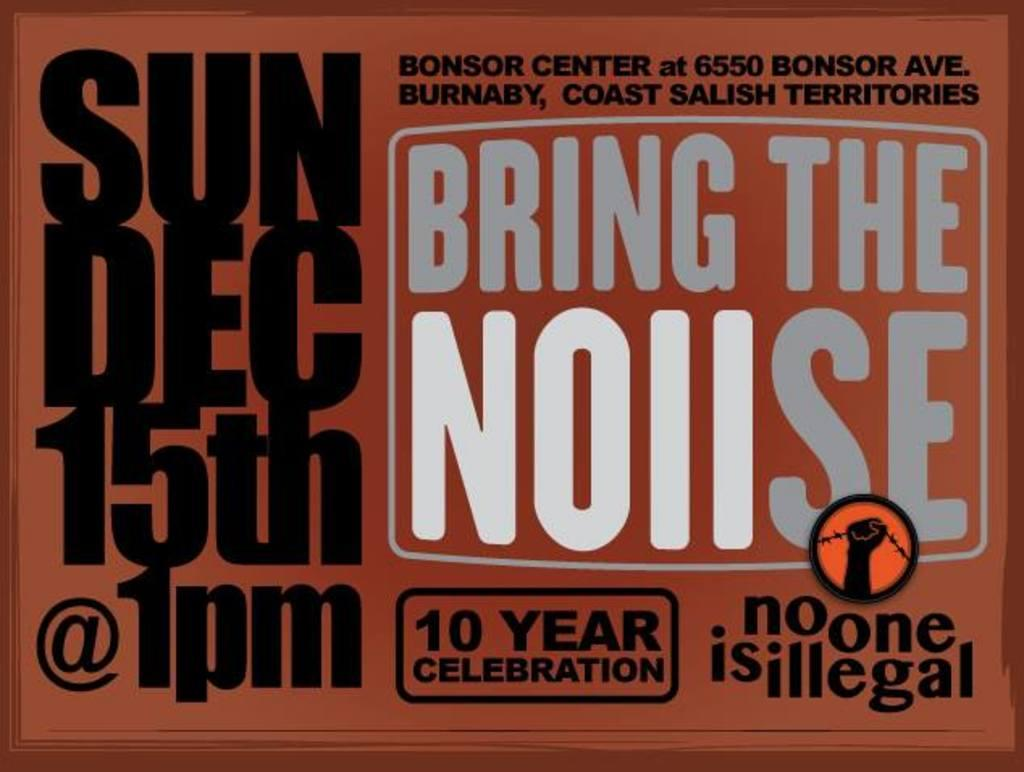<image>
Offer a succinct explanation of the picture presented. Sign that says that Bring The Noiise will be on December 15th. 